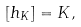<formula> <loc_0><loc_0><loc_500><loc_500>[ h _ { K } ] = K ,</formula> 